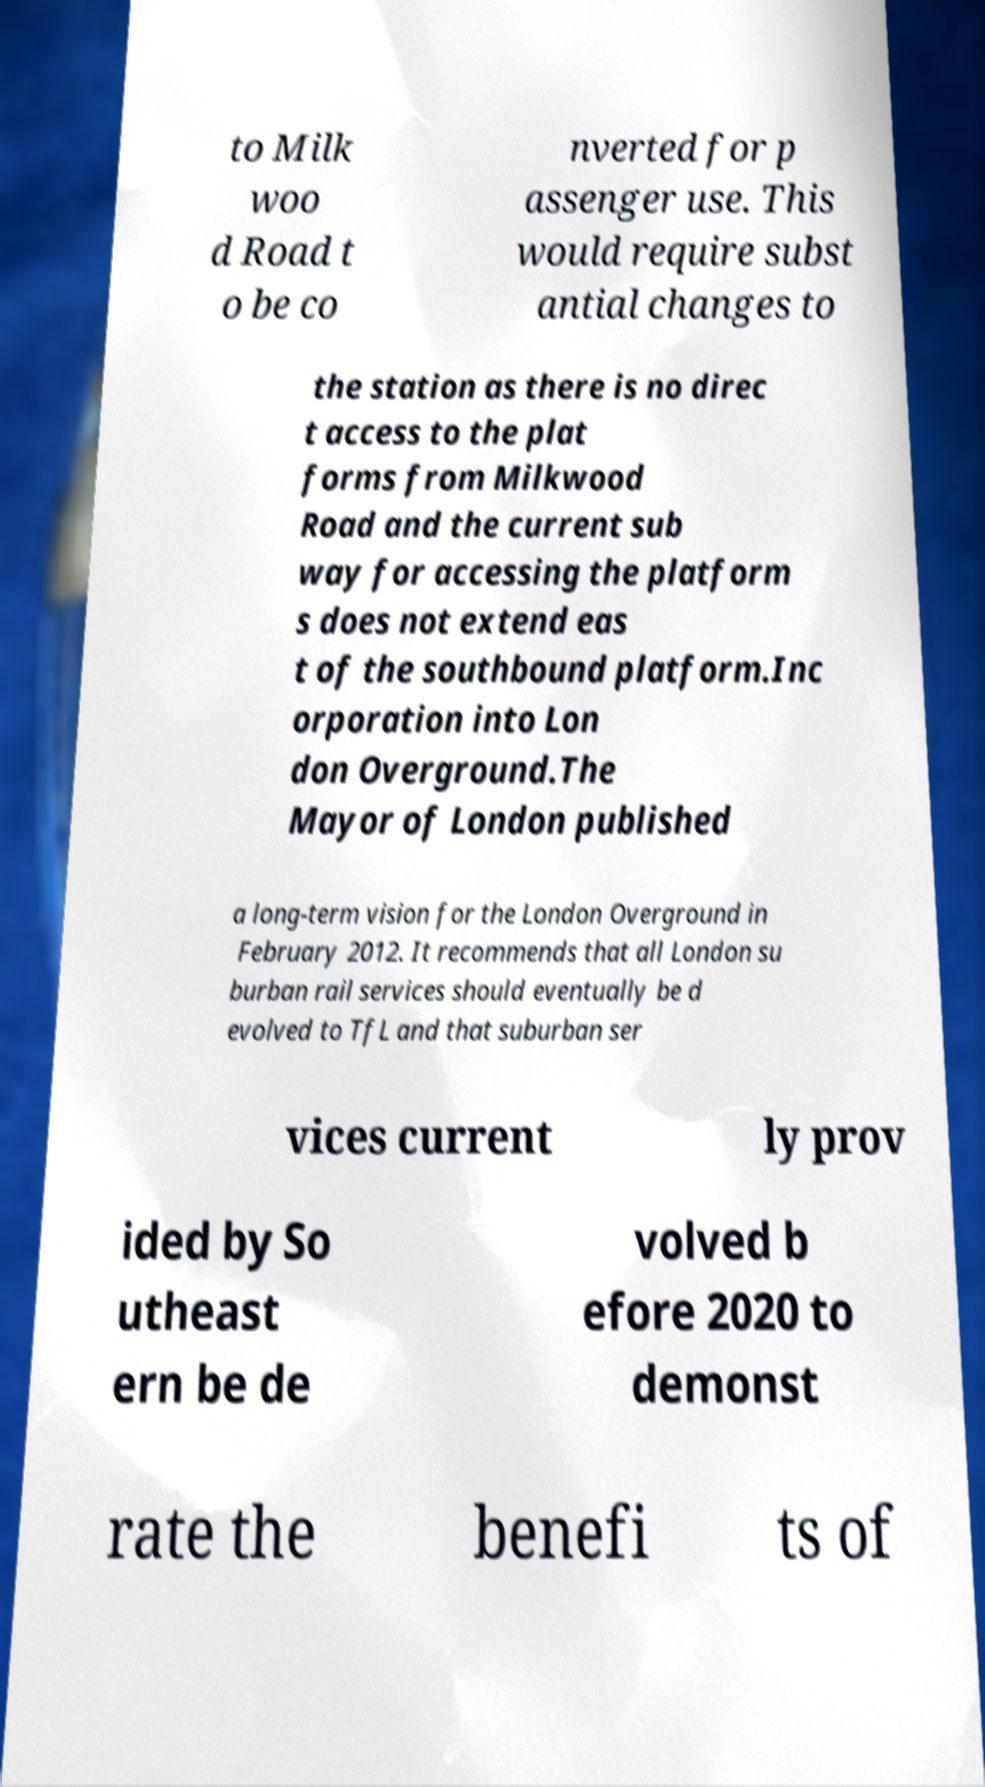Could you assist in decoding the text presented in this image and type it out clearly? to Milk woo d Road t o be co nverted for p assenger use. This would require subst antial changes to the station as there is no direc t access to the plat forms from Milkwood Road and the current sub way for accessing the platform s does not extend eas t of the southbound platform.Inc orporation into Lon don Overground.The Mayor of London published a long-term vision for the London Overground in February 2012. It recommends that all London su burban rail services should eventually be d evolved to TfL and that suburban ser vices current ly prov ided by So utheast ern be de volved b efore 2020 to demonst rate the benefi ts of 